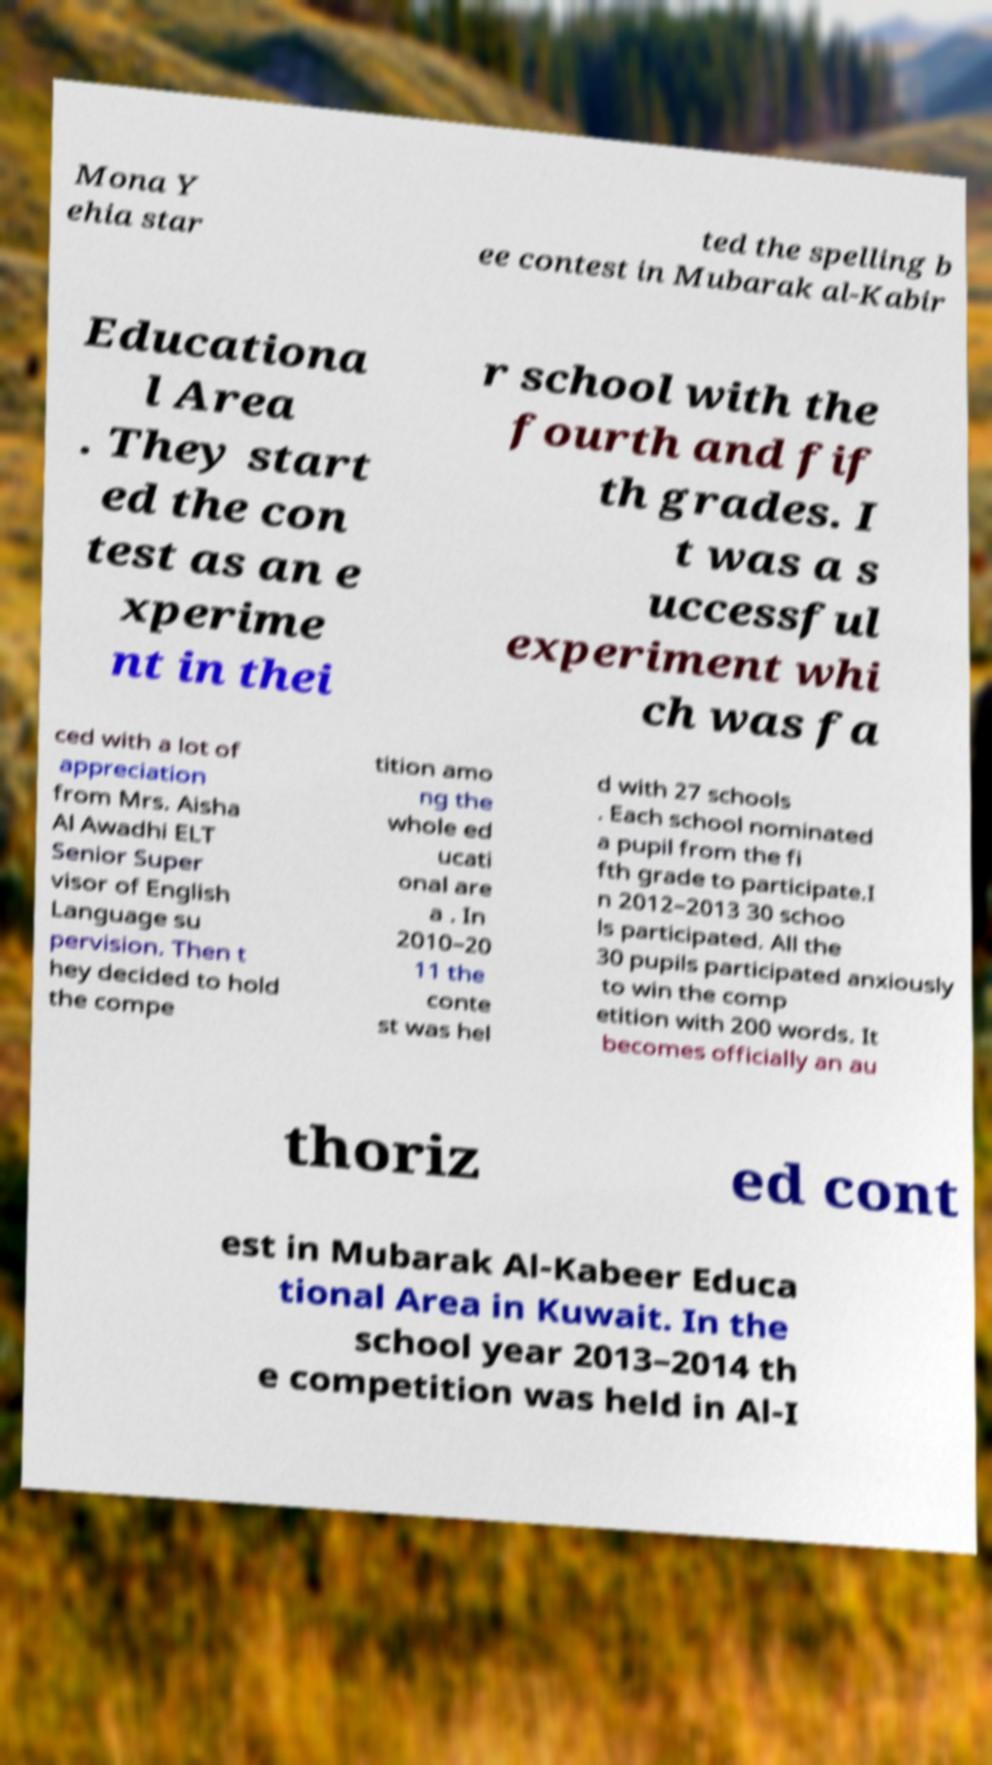Can you accurately transcribe the text from the provided image for me? Mona Y ehia star ted the spelling b ee contest in Mubarak al-Kabir Educationa l Area . They start ed the con test as an e xperime nt in thei r school with the fourth and fif th grades. I t was a s uccessful experiment whi ch was fa ced with a lot of appreciation from Mrs. Aisha Al Awadhi ELT Senior Super visor of English Language su pervision. Then t hey decided to hold the compe tition amo ng the whole ed ucati onal are a . In 2010–20 11 the conte st was hel d with 27 schools . Each school nominated a pupil from the fi fth grade to participate.I n 2012–2013 30 schoo ls participated. All the 30 pupils participated anxiously to win the comp etition with 200 words. It becomes officially an au thoriz ed cont est in Mubarak Al-Kabeer Educa tional Area in Kuwait. In the school year 2013–2014 th e competition was held in Al-I 